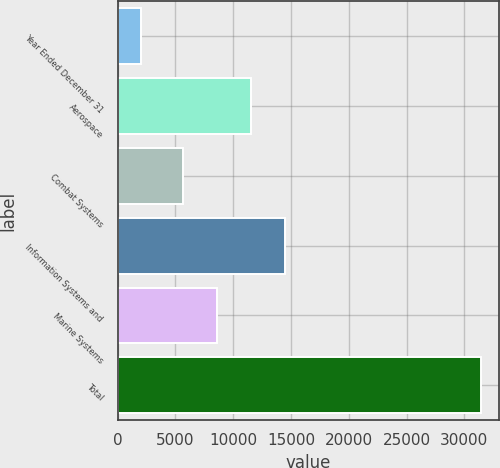Convert chart to OTSL. <chart><loc_0><loc_0><loc_500><loc_500><bar_chart><fcel>Year Ended December 31<fcel>Aerospace<fcel>Combat Systems<fcel>Information Systems and<fcel>Marine Systems<fcel>Total<nl><fcel>2015<fcel>11530.8<fcel>5640<fcel>14476.2<fcel>8585.4<fcel>31469<nl></chart> 